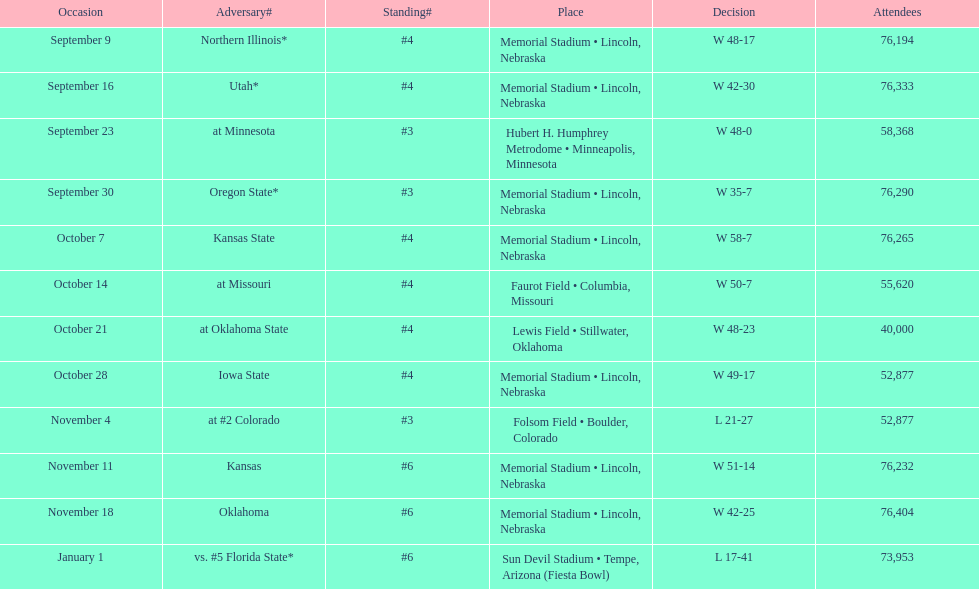What's the number of people who attended the oregon state game? 76,290. 